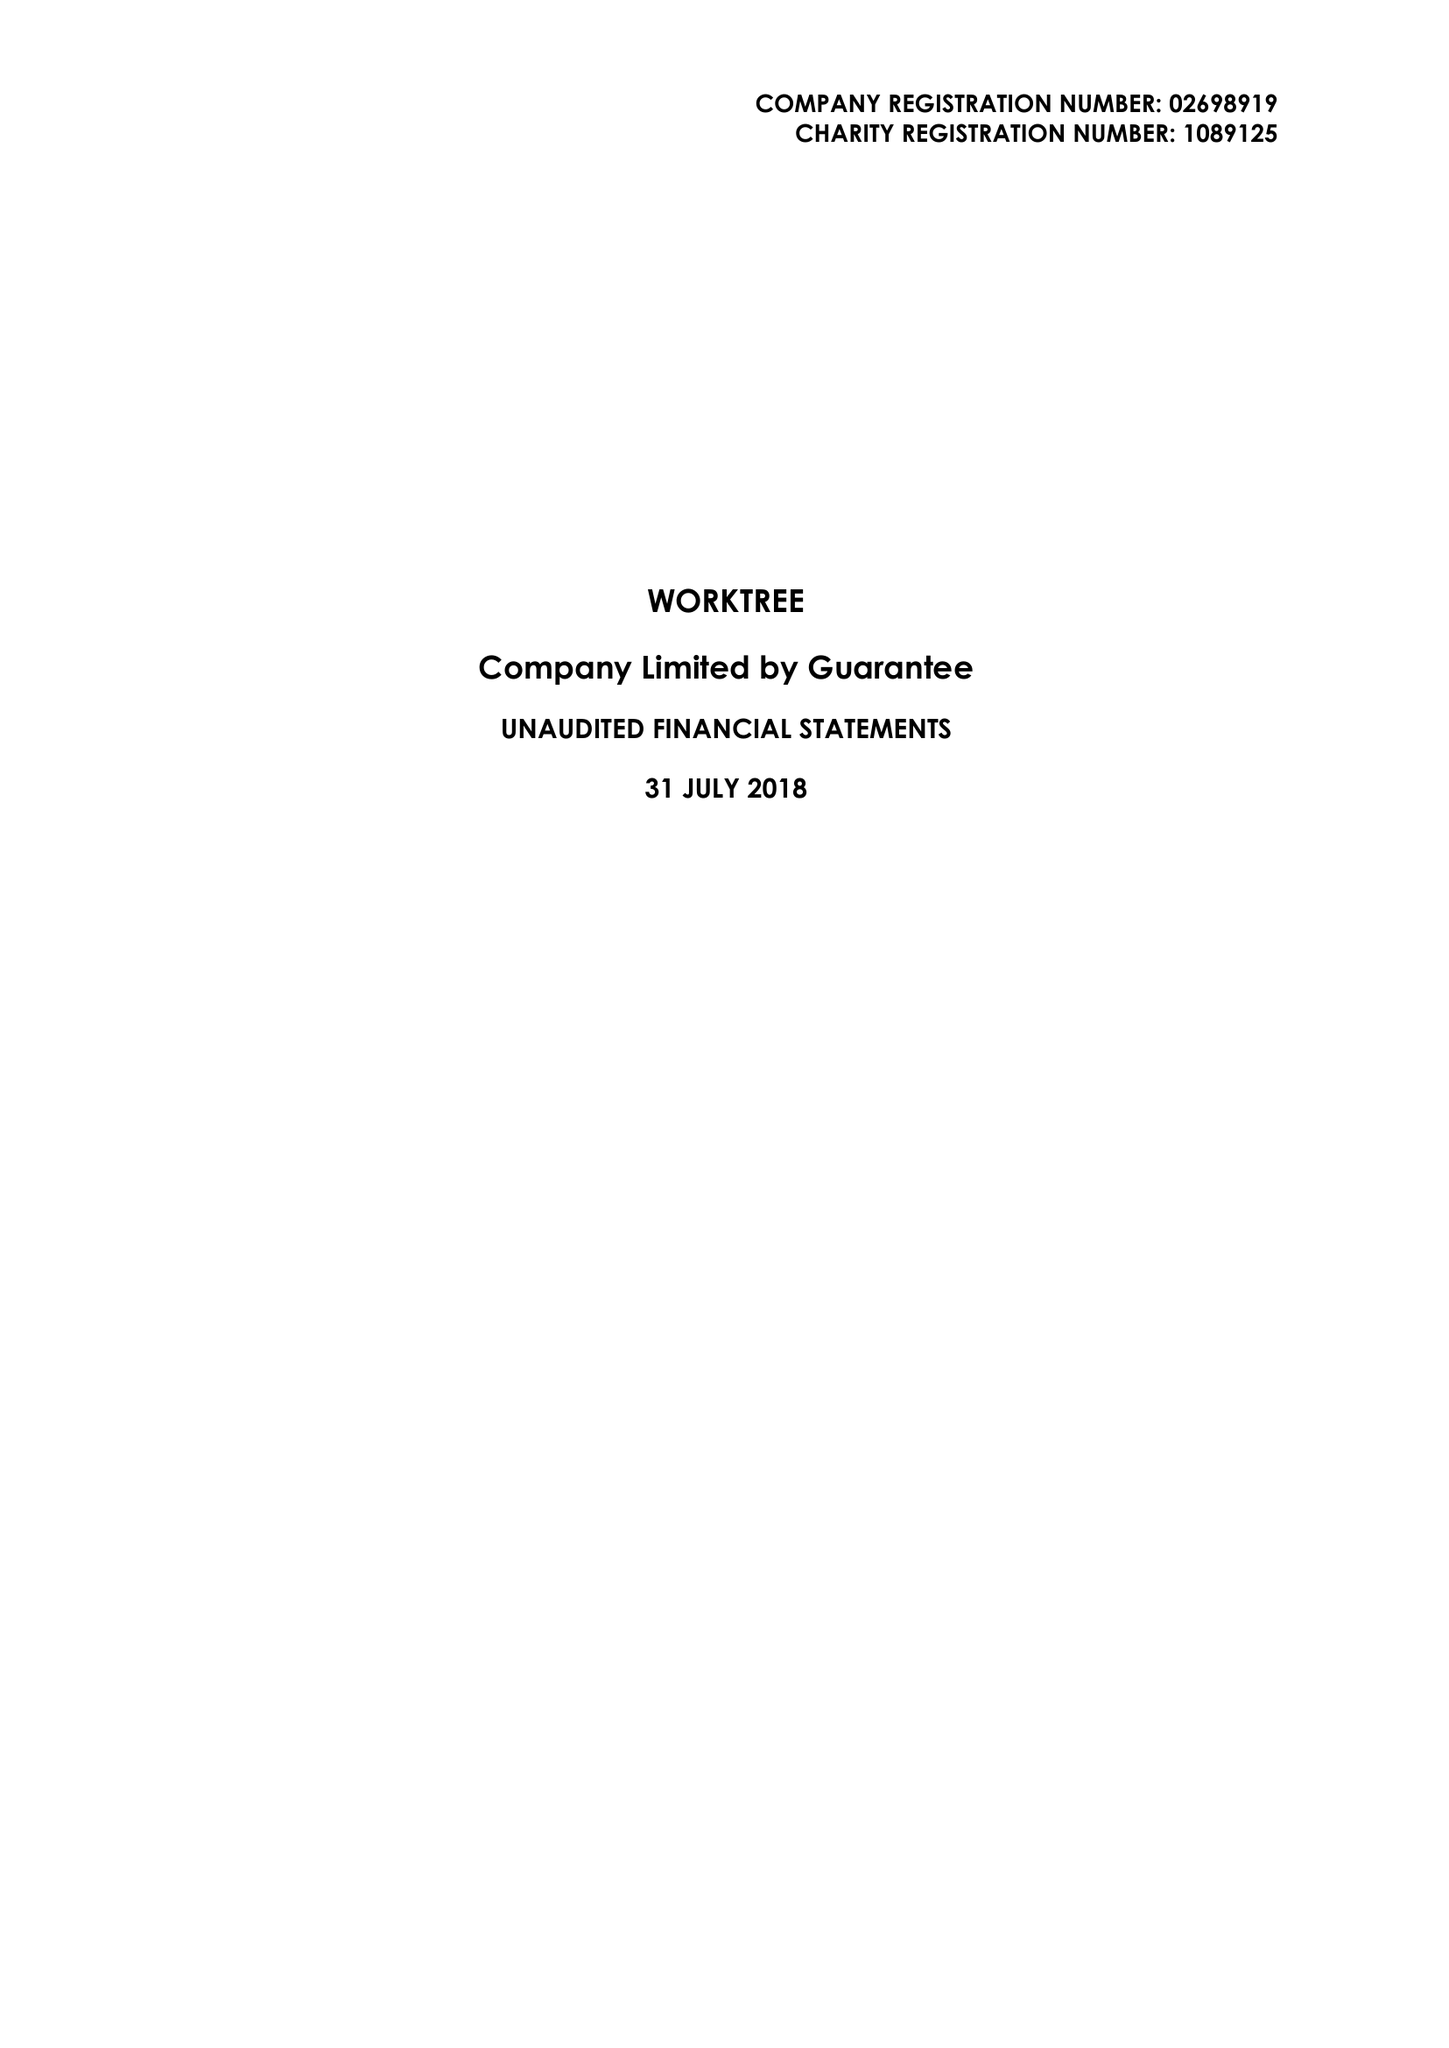What is the value for the address__post_town?
Answer the question using a single word or phrase. MILTON KEYNES 